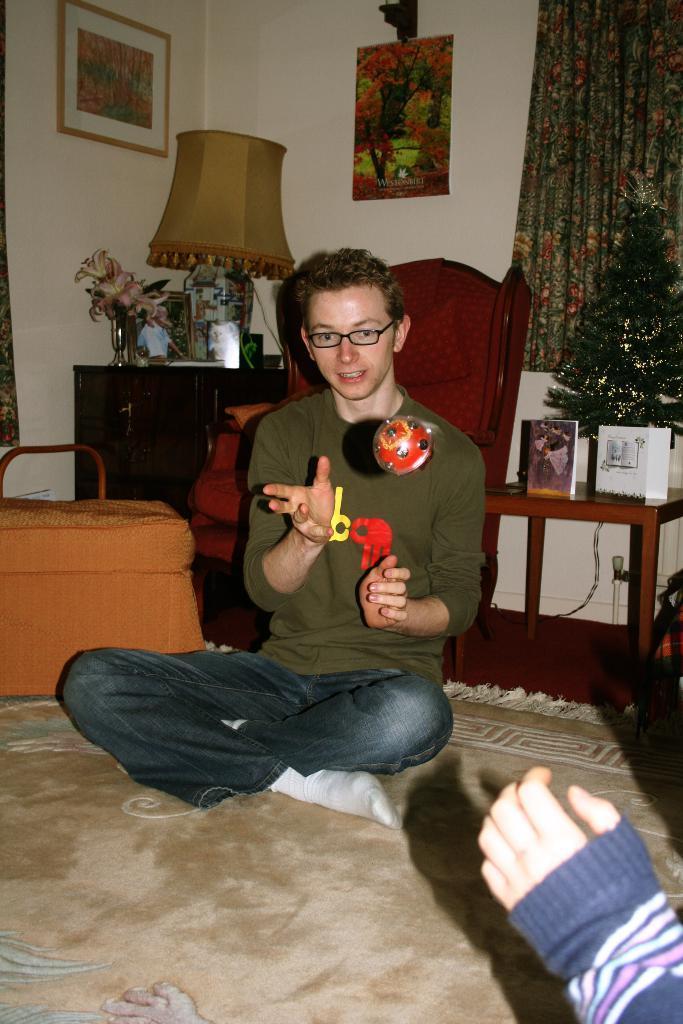How would you summarize this image in a sentence or two? This image is clicked inside the room. There is a man sitting and playing with a ball. He is wearing blue jeans. To the left, there is a bag. In the background, there is a lamp and frames on the wall. To the right, there is a Xmas tree and a curtain. 